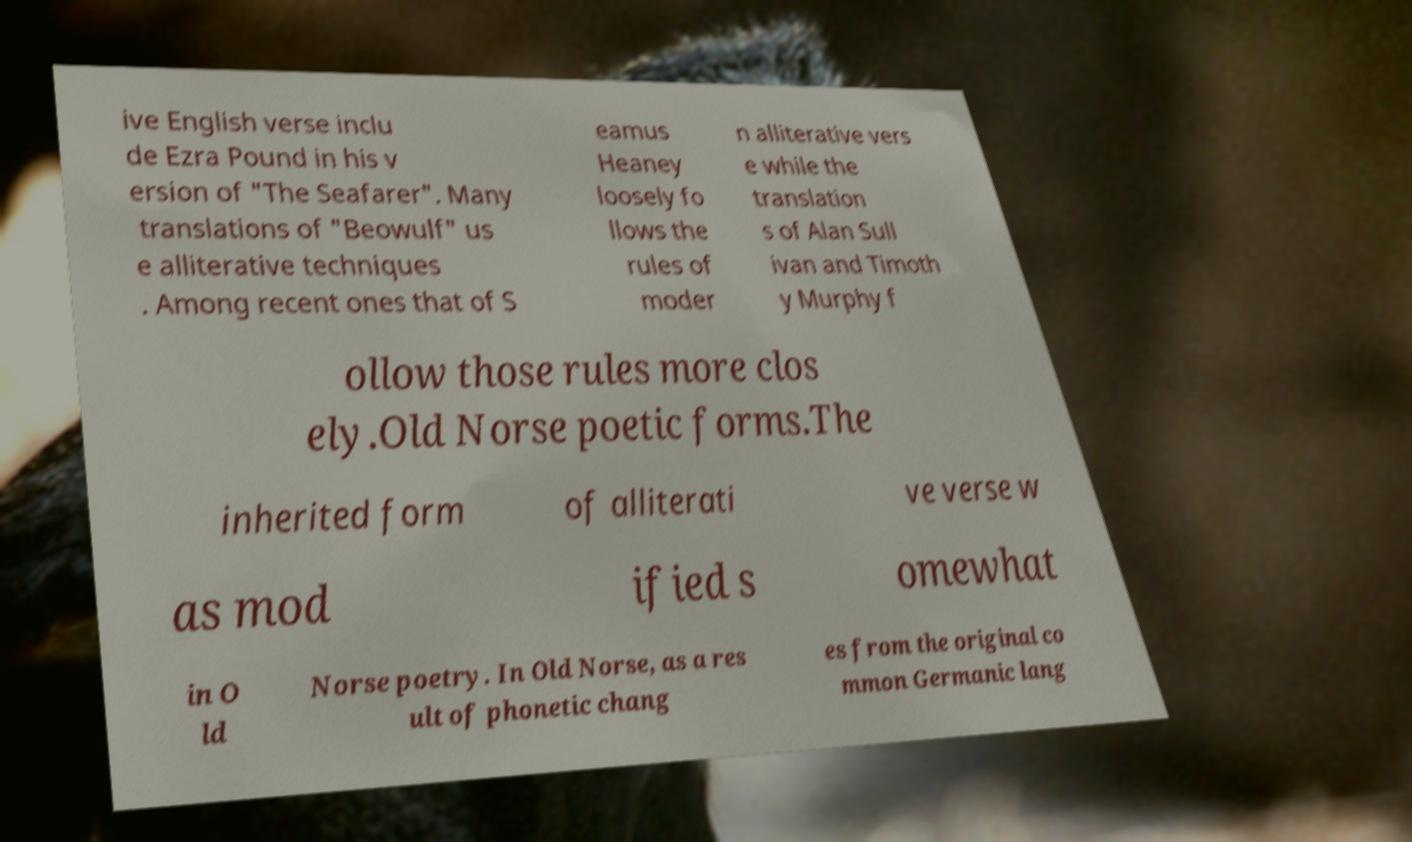Please read and relay the text visible in this image. What does it say? ive English verse inclu de Ezra Pound in his v ersion of "The Seafarer". Many translations of "Beowulf" us e alliterative techniques . Among recent ones that of S eamus Heaney loosely fo llows the rules of moder n alliterative vers e while the translation s of Alan Sull ivan and Timoth y Murphy f ollow those rules more clos ely.Old Norse poetic forms.The inherited form of alliterati ve verse w as mod ified s omewhat in O ld Norse poetry. In Old Norse, as a res ult of phonetic chang es from the original co mmon Germanic lang 